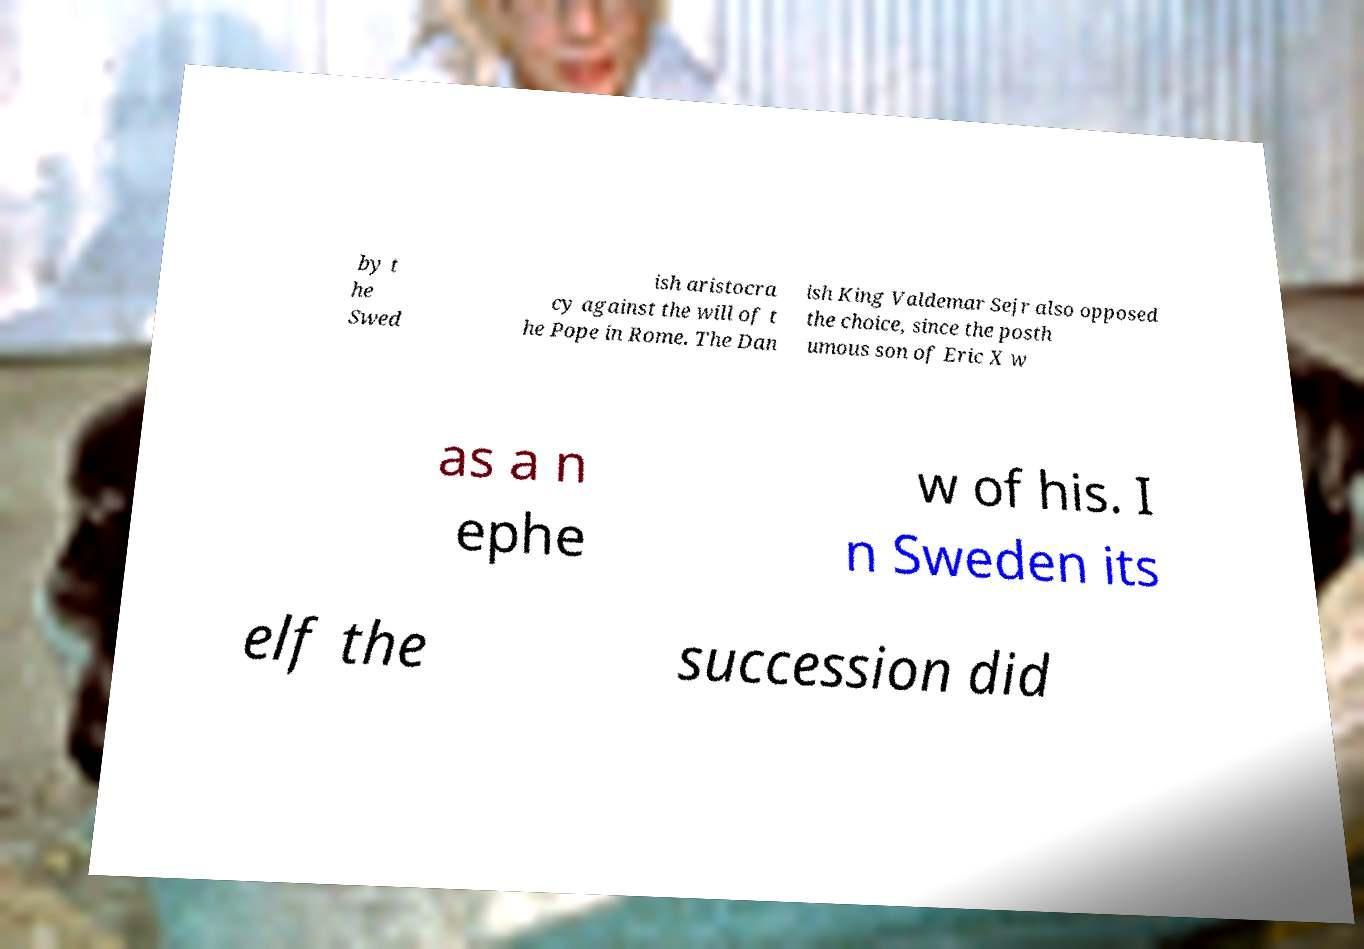Can you read and provide the text displayed in the image?This photo seems to have some interesting text. Can you extract and type it out for me? by t he Swed ish aristocra cy against the will of t he Pope in Rome. The Dan ish King Valdemar Sejr also opposed the choice, since the posth umous son of Eric X w as a n ephe w of his. I n Sweden its elf the succession did 